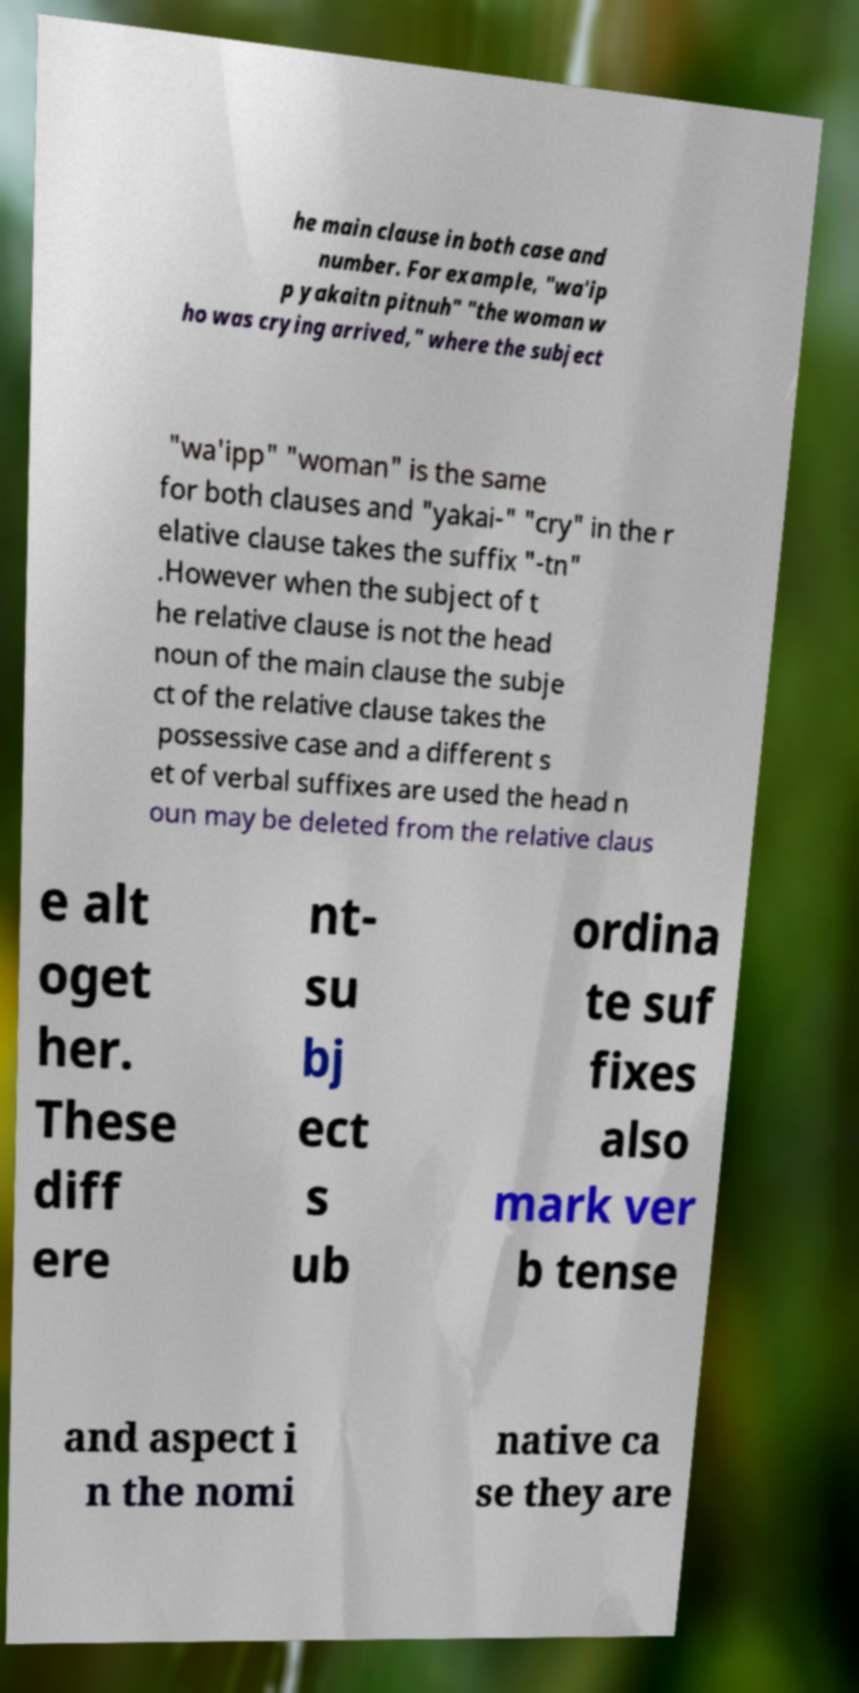Could you extract and type out the text from this image? he main clause in both case and number. For example, "wa'ip p yakaitn pitnuh" "the woman w ho was crying arrived," where the subject "wa'ipp" "woman" is the same for both clauses and "yakai-" "cry" in the r elative clause takes the suffix "-tn" .However when the subject of t he relative clause is not the head noun of the main clause the subje ct of the relative clause takes the possessive case and a different s et of verbal suffixes are used the head n oun may be deleted from the relative claus e alt oget her. These diff ere nt- su bj ect s ub ordina te suf fixes also mark ver b tense and aspect i n the nomi native ca se they are 